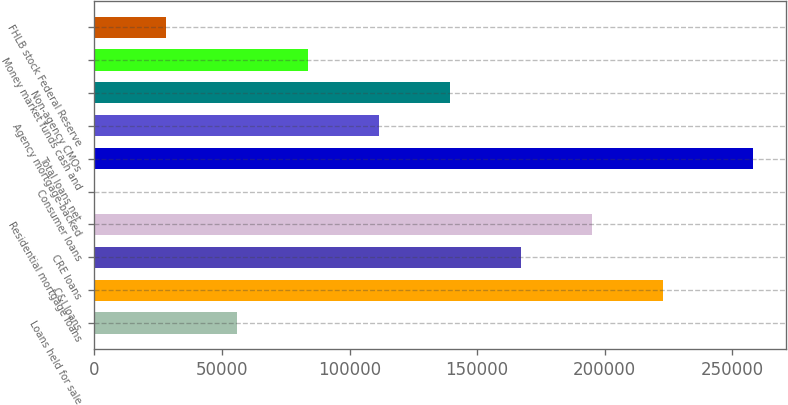<chart> <loc_0><loc_0><loc_500><loc_500><bar_chart><fcel>Loans held for sale<fcel>C&I loans<fcel>CRE loans<fcel>Residential mortgage loans<fcel>Consumer loans<fcel>Total loans net<fcel>Agency mortgage-backed<fcel>Non-agency CMOs<fcel>Money market funds cash and<fcel>FHLB stock Federal Reserve<nl><fcel>56010.8<fcel>222747<fcel>167168<fcel>194958<fcel>432<fcel>257988<fcel>111590<fcel>139379<fcel>83800.2<fcel>28221.4<nl></chart> 